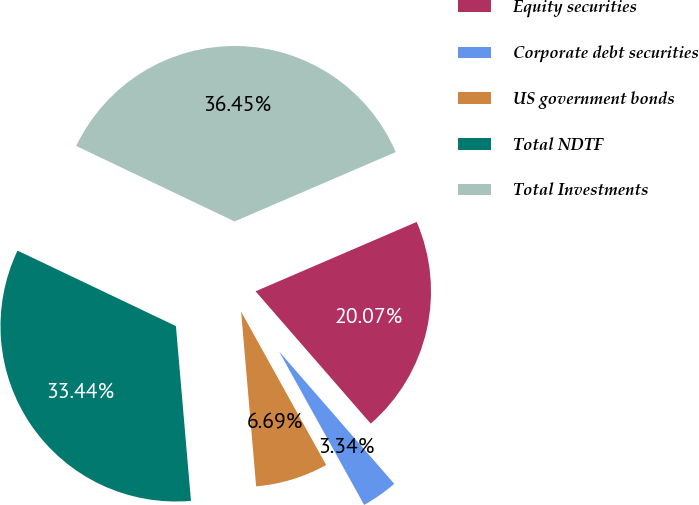Convert chart to OTSL. <chart><loc_0><loc_0><loc_500><loc_500><pie_chart><fcel>Equity securities<fcel>Corporate debt securities<fcel>US government bonds<fcel>Total NDTF<fcel>Total Investments<nl><fcel>20.07%<fcel>3.34%<fcel>6.69%<fcel>33.44%<fcel>36.45%<nl></chart> 